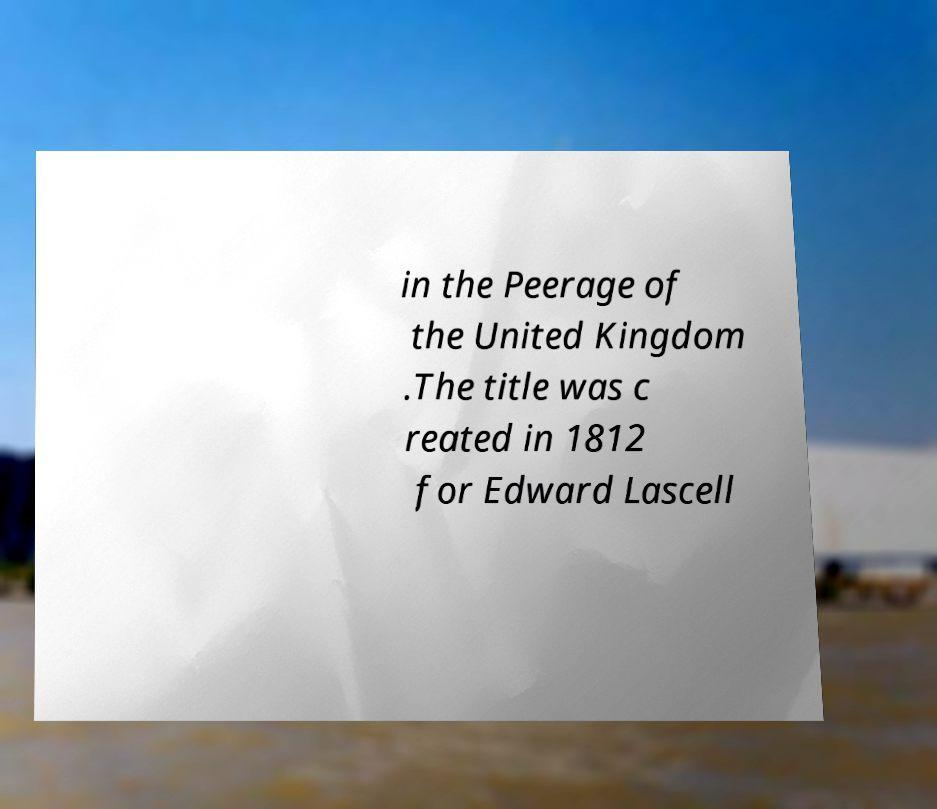Please read and relay the text visible in this image. What does it say? in the Peerage of the United Kingdom .The title was c reated in 1812 for Edward Lascell 